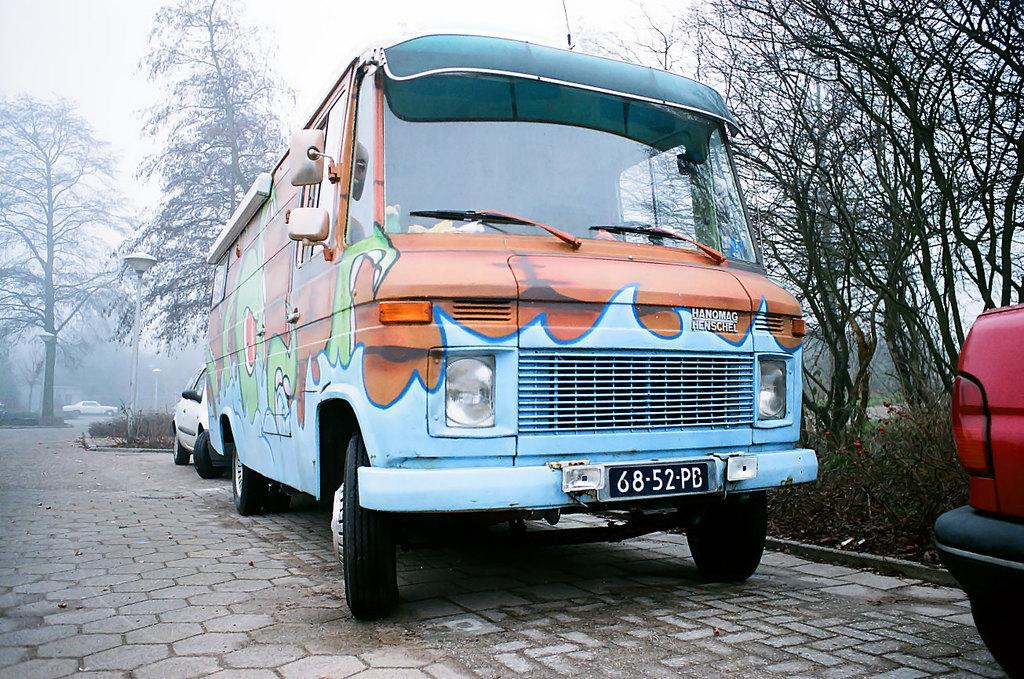<image>
Write a terse but informative summary of the picture. A bus with the license plate number of 68-52-PB is eccentrically painted. 